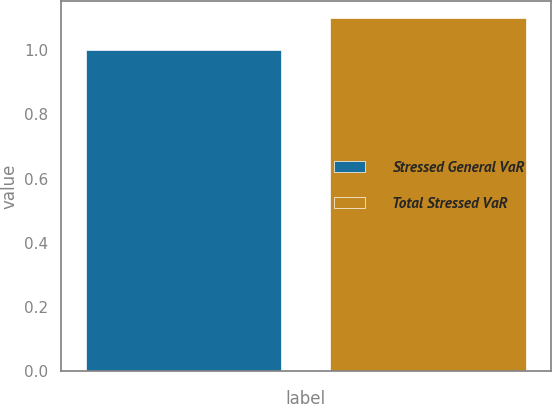Convert chart to OTSL. <chart><loc_0><loc_0><loc_500><loc_500><bar_chart><fcel>Stressed General VaR<fcel>Total Stressed VaR<nl><fcel>1<fcel>1.1<nl></chart> 